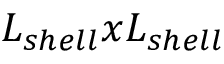<formula> <loc_0><loc_0><loc_500><loc_500>L _ { s h e l l } x L _ { s h e l l }</formula> 